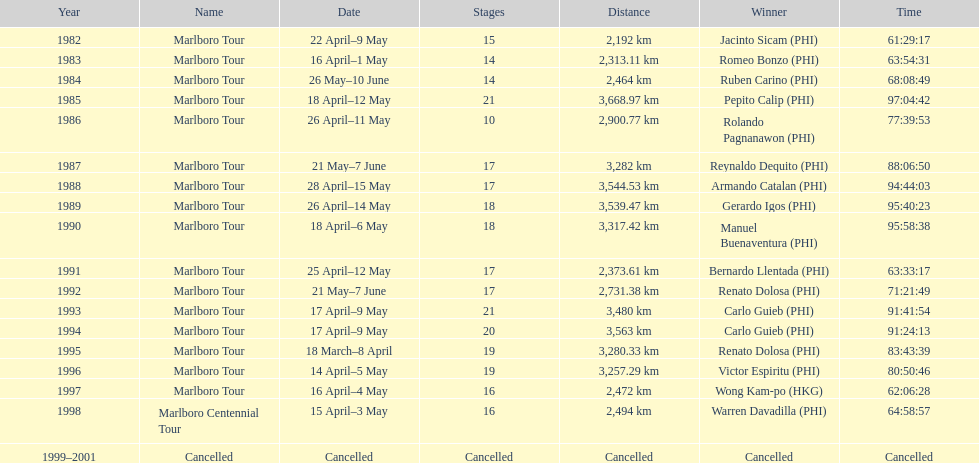Whose name is listed just ahead of wong kam-po? Victor Espiritu (PHI). 